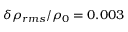<formula> <loc_0><loc_0><loc_500><loc_500>\delta \rho _ { r m s } / \rho _ { 0 } = 0 . 0 0 3</formula> 